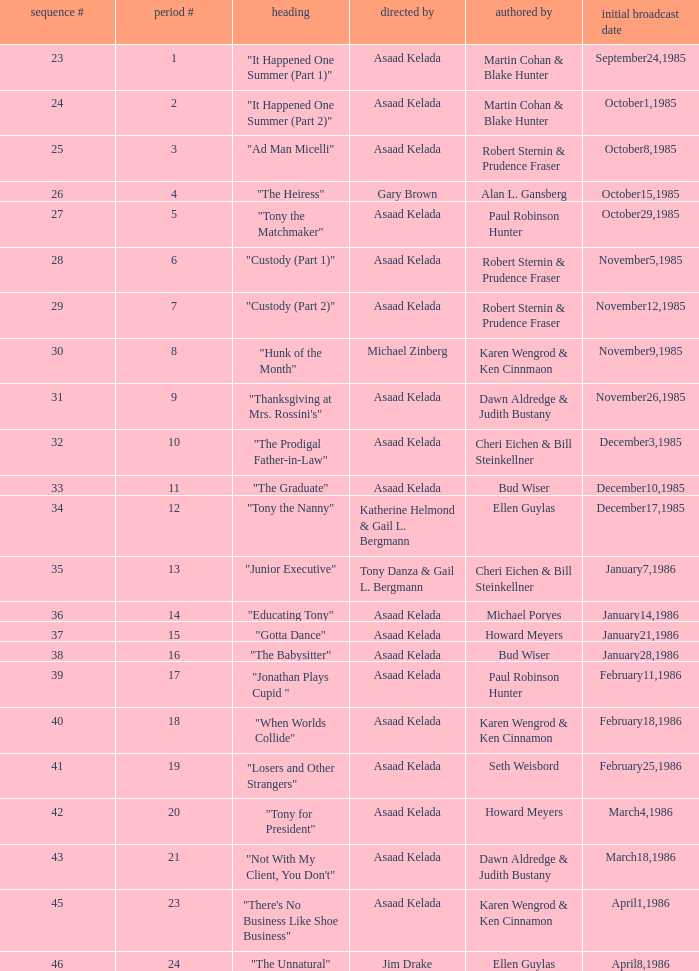What season features writer Michael Poryes? 14.0. 